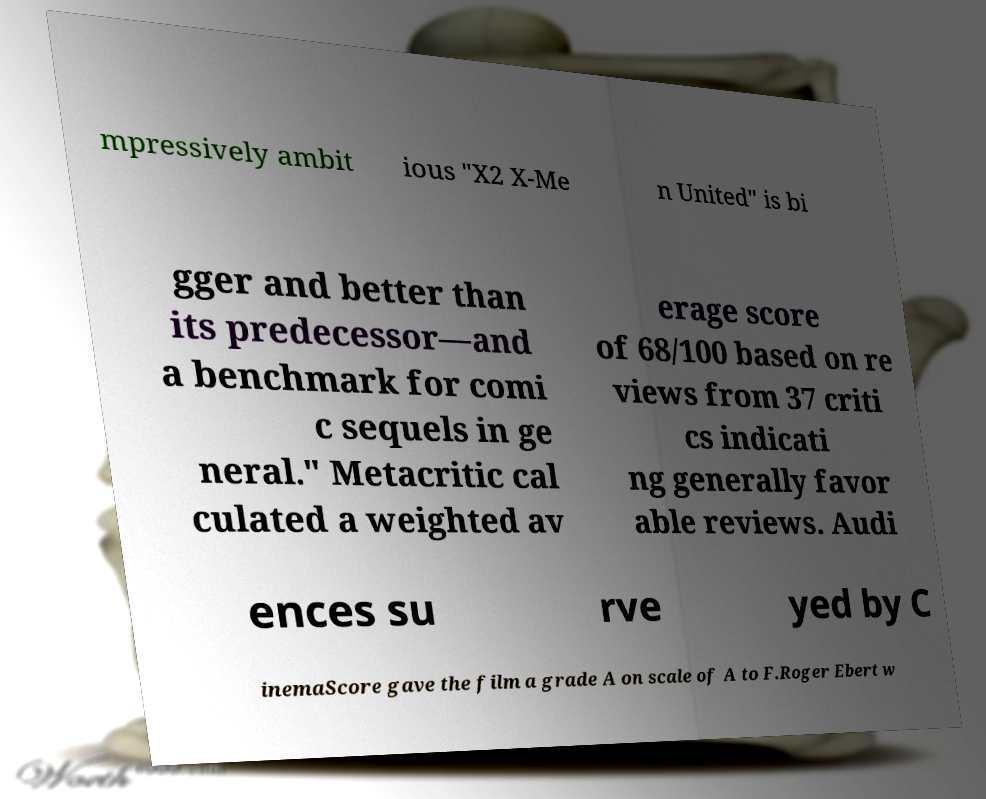Can you read and provide the text displayed in the image?This photo seems to have some interesting text. Can you extract and type it out for me? mpressively ambit ious "X2 X-Me n United" is bi gger and better than its predecessor—and a benchmark for comi c sequels in ge neral." Metacritic cal culated a weighted av erage score of 68/100 based on re views from 37 criti cs indicati ng generally favor able reviews. Audi ences su rve yed by C inemaScore gave the film a grade A on scale of A to F.Roger Ebert w 